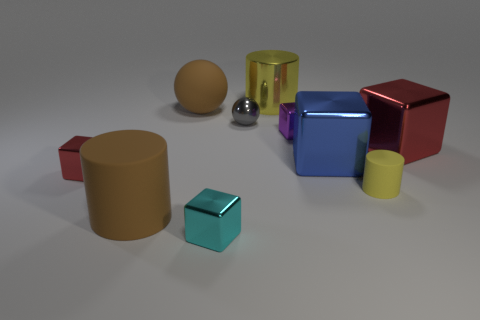Are there any other things that have the same material as the cyan thing?
Keep it short and to the point. Yes. There is a big matte object that is the same color as the big ball; what shape is it?
Provide a short and direct response. Cylinder. What number of other objects are there of the same color as the tiny rubber cylinder?
Ensure brevity in your answer.  1. How many other things are there of the same size as the blue metal thing?
Your response must be concise. 4. Are there an equal number of small purple metal cubes that are behind the tiny gray metal sphere and yellow metallic cylinders that are in front of the big blue block?
Provide a short and direct response. Yes. What is the color of the other large metallic thing that is the same shape as the blue thing?
Offer a terse response. Red. Is there anything else that has the same shape as the tiny purple metal object?
Ensure brevity in your answer.  Yes. Do the tiny metallic cube to the right of the small sphere and the tiny cylinder have the same color?
Keep it short and to the point. No. There is a purple metallic thing that is the same shape as the big blue thing; what is its size?
Provide a succinct answer. Small. What number of blocks are the same material as the small cyan object?
Offer a very short reply. 4. 